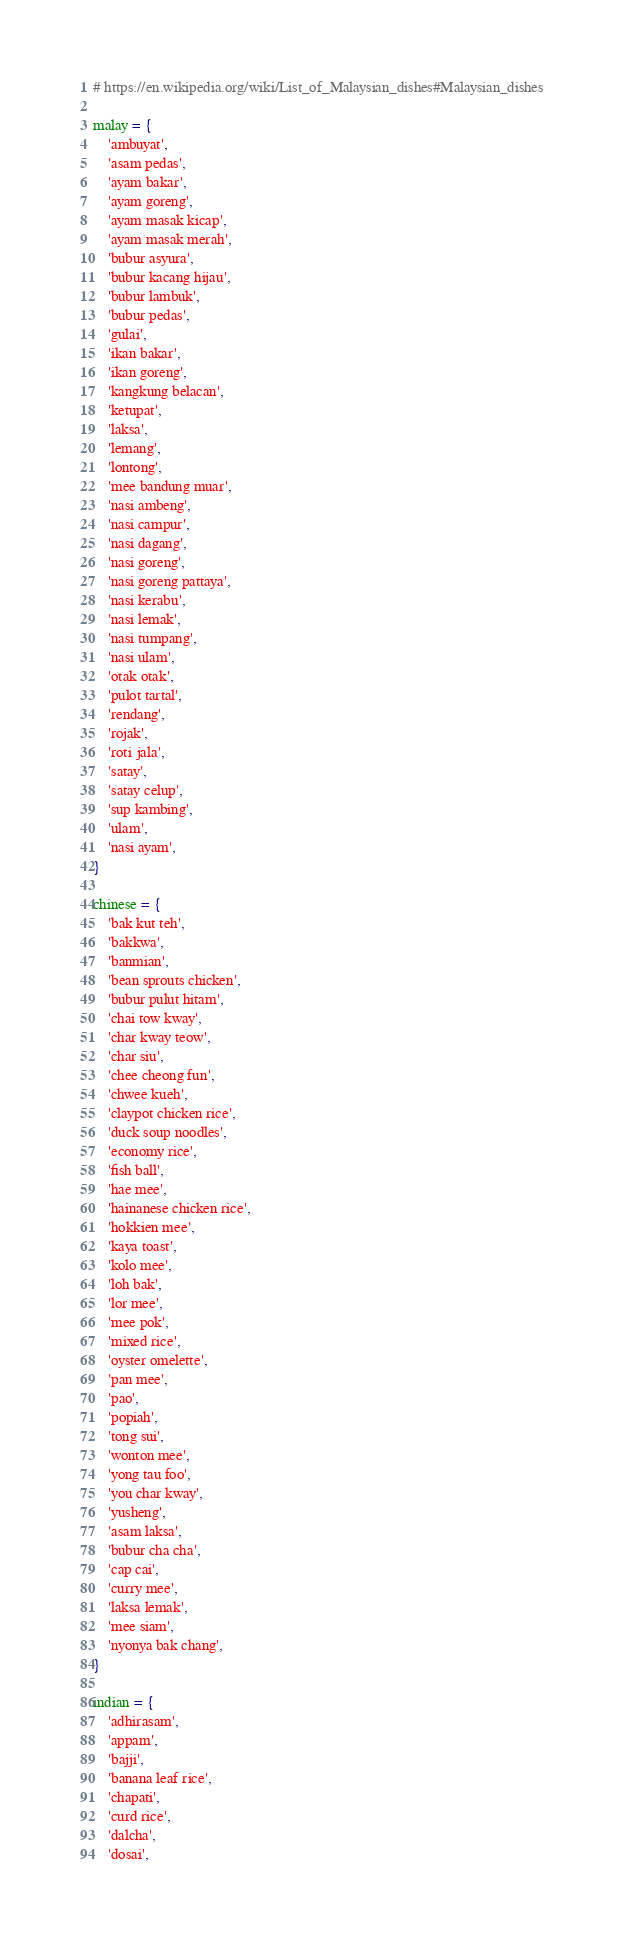<code> <loc_0><loc_0><loc_500><loc_500><_Python_># https://en.wikipedia.org/wiki/List_of_Malaysian_dishes#Malaysian_dishes

malay = {
    'ambuyat',
    'asam pedas',
    'ayam bakar',
    'ayam goreng',
    'ayam masak kicap',
    'ayam masak merah',
    'bubur asyura',
    'bubur kacang hijau',
    'bubur lambuk',
    'bubur pedas',
    'gulai',
    'ikan bakar',
    'ikan goreng',
    'kangkung belacan',
    'ketupat',
    'laksa',
    'lemang',
    'lontong',
    'mee bandung muar',
    'nasi ambeng',
    'nasi campur',
    'nasi dagang',
    'nasi goreng',
    'nasi goreng pattaya',
    'nasi kerabu',
    'nasi lemak',
    'nasi tumpang',
    'nasi ulam',
    'otak otak',
    'pulot tartal',
    'rendang',
    'rojak',
    'roti jala',
    'satay',
    'satay celup',
    'sup kambing',
    'ulam',
    'nasi ayam',
}

chinese = {
    'bak kut teh',
    'bakkwa',
    'banmian',
    'bean sprouts chicken',
    'bubur pulut hitam',
    'chai tow kway',
    'char kway teow',
    'char siu',
    'chee cheong fun',
    'chwee kueh',
    'claypot chicken rice',
    'duck soup noodles',
    'economy rice',
    'fish ball',
    'hae mee',
    'hainanese chicken rice',
    'hokkien mee',
    'kaya toast',
    'kolo mee',
    'loh bak',
    'lor mee',
    'mee pok',
    'mixed rice',
    'oyster omelette',
    'pan mee',
    'pao',
    'popiah',
    'tong sui',
    'wonton mee',
    'yong tau foo',
    'you char kway',
    'yusheng',
    'asam laksa',
    'bubur cha cha',
    'cap cai',
    'curry mee',
    'laksa lemak',
    'mee siam',
    'nyonya bak chang',
}

indian = {
    'adhirasam',
    'appam',
    'bajji',
    'banana leaf rice',
    'chapati',
    'curd rice',
    'dalcha',
    'dosai',</code> 